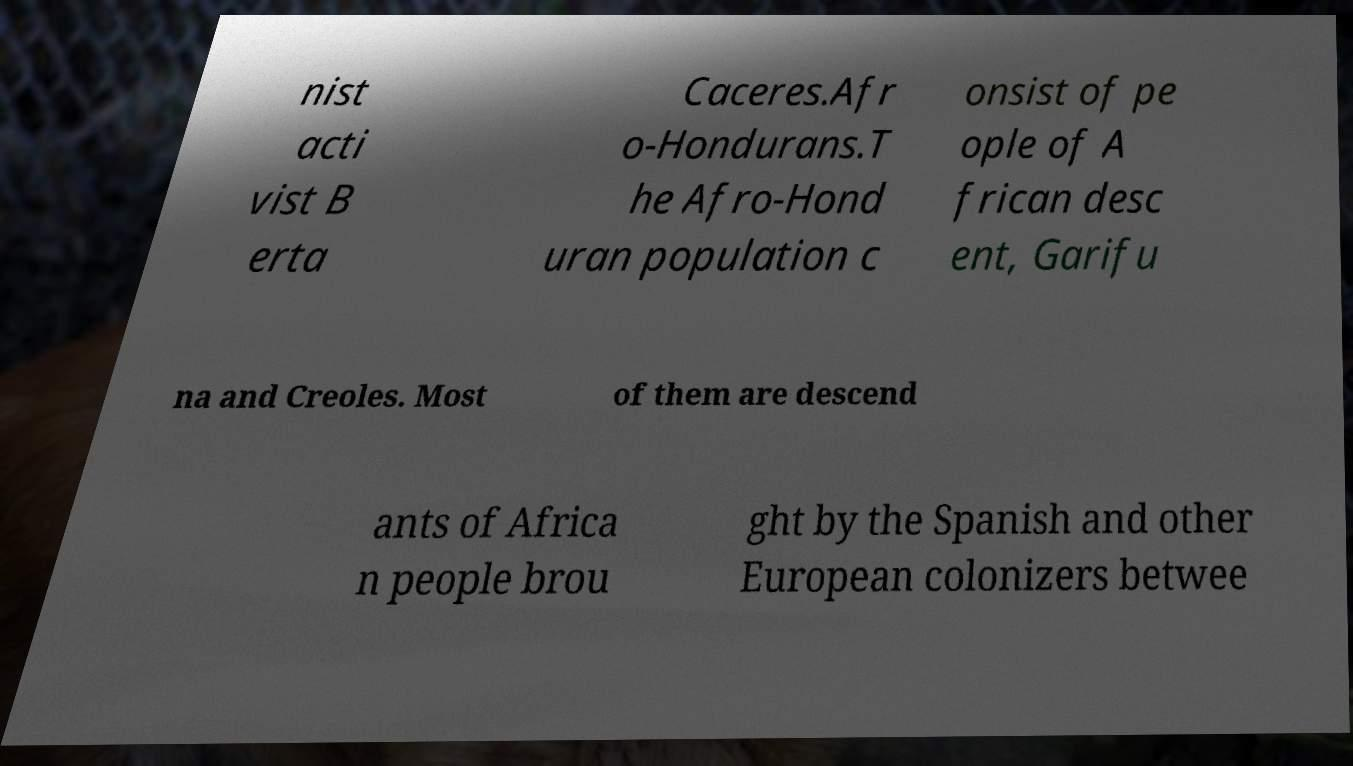Please read and relay the text visible in this image. What does it say? nist acti vist B erta Caceres.Afr o-Hondurans.T he Afro-Hond uran population c onsist of pe ople of A frican desc ent, Garifu na and Creoles. Most of them are descend ants of Africa n people brou ght by the Spanish and other European colonizers betwee 